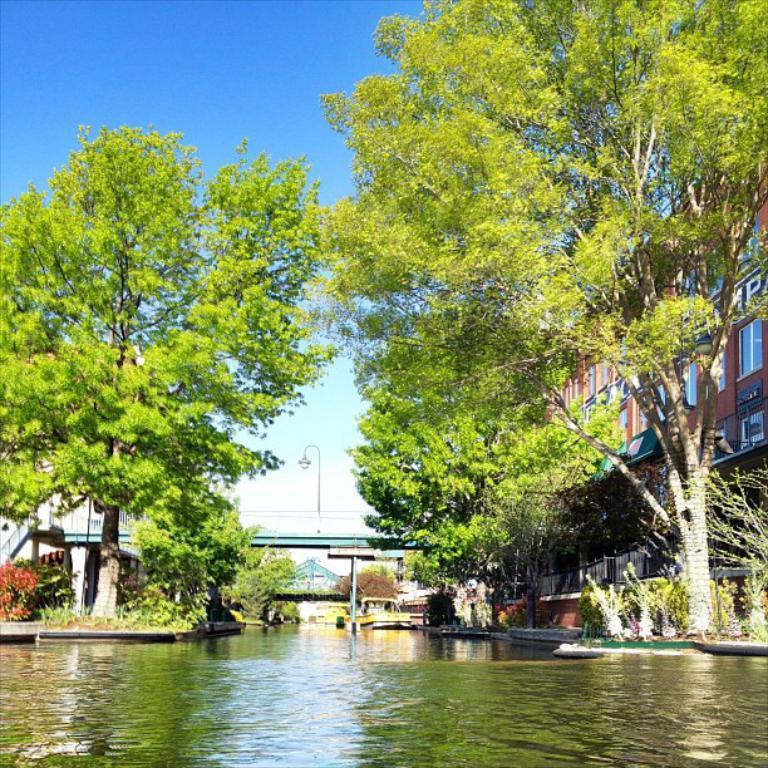Could you give a brief overview of what you see in this image? In this image we can see bridge, trees, houses, buildings, water, plants, boats, sky and clouds. 